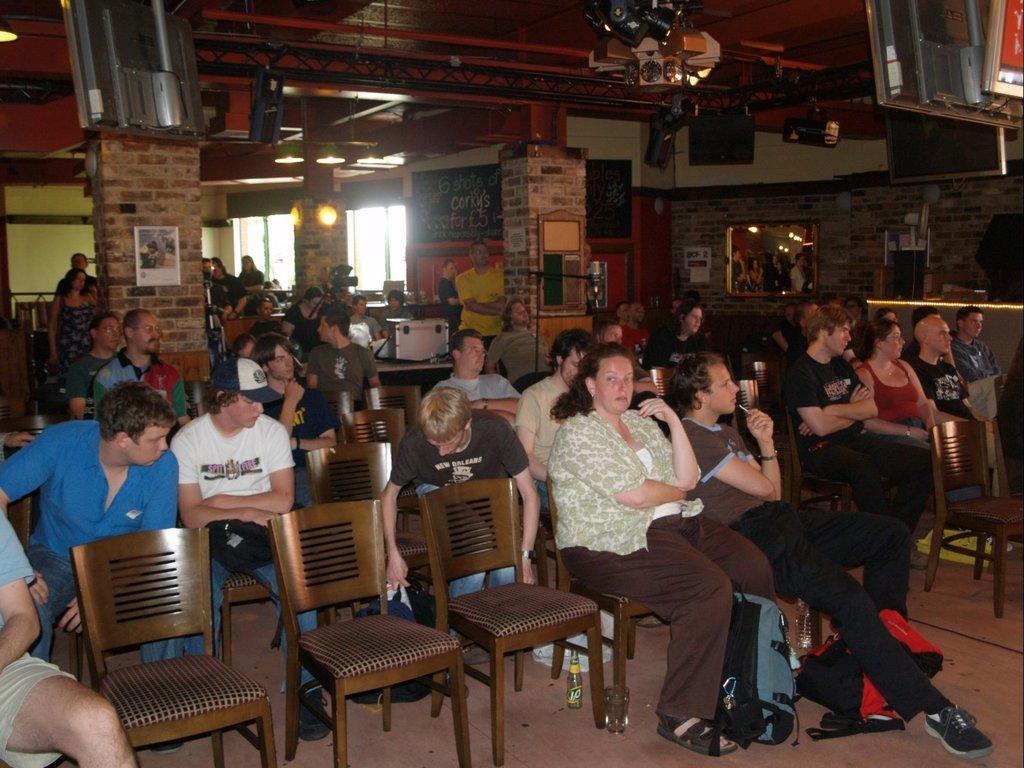Can you describe this image briefly? The place seems to be a restaurant, there is a meeting going on group of people sitting in the chairs and paying attention towards something, in the background there is a black color board, some pillars, a window, and a brick wall. 